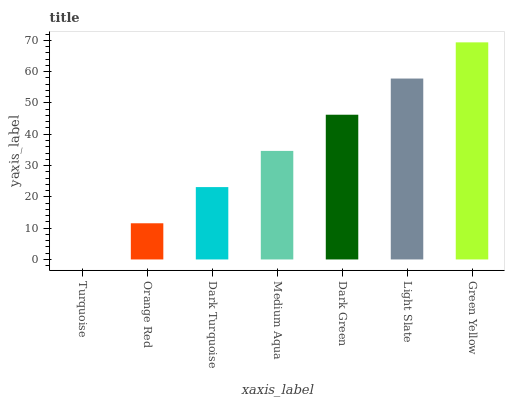Is Turquoise the minimum?
Answer yes or no. Yes. Is Green Yellow the maximum?
Answer yes or no. Yes. Is Orange Red the minimum?
Answer yes or no. No. Is Orange Red the maximum?
Answer yes or no. No. Is Orange Red greater than Turquoise?
Answer yes or no. Yes. Is Turquoise less than Orange Red?
Answer yes or no. Yes. Is Turquoise greater than Orange Red?
Answer yes or no. No. Is Orange Red less than Turquoise?
Answer yes or no. No. Is Medium Aqua the high median?
Answer yes or no. Yes. Is Medium Aqua the low median?
Answer yes or no. Yes. Is Green Yellow the high median?
Answer yes or no. No. Is Dark Green the low median?
Answer yes or no. No. 